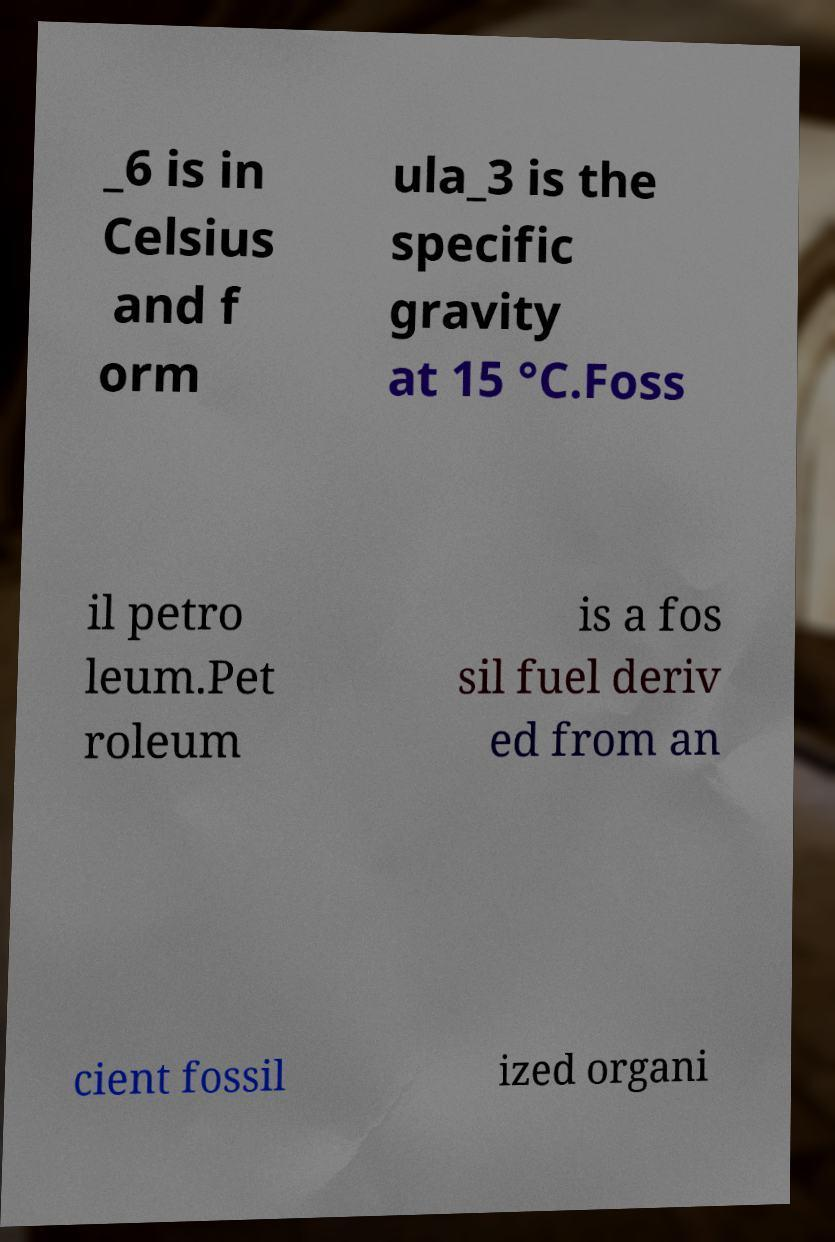What messages or text are displayed in this image? I need them in a readable, typed format. _6 is in Celsius and f orm ula_3 is the specific gravity at 15 °C.Foss il petro leum.Pet roleum is a fos sil fuel deriv ed from an cient fossil ized organi 